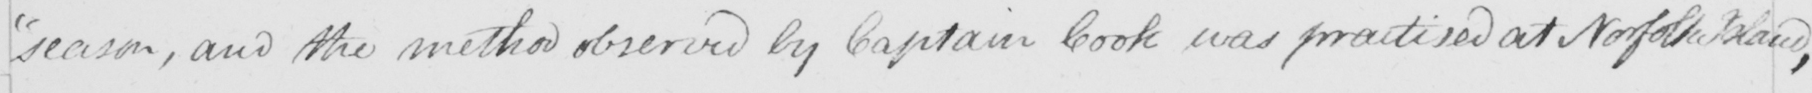What does this handwritten line say? season , and the method observed by Captain Cook was practised at Norfolk Island , 